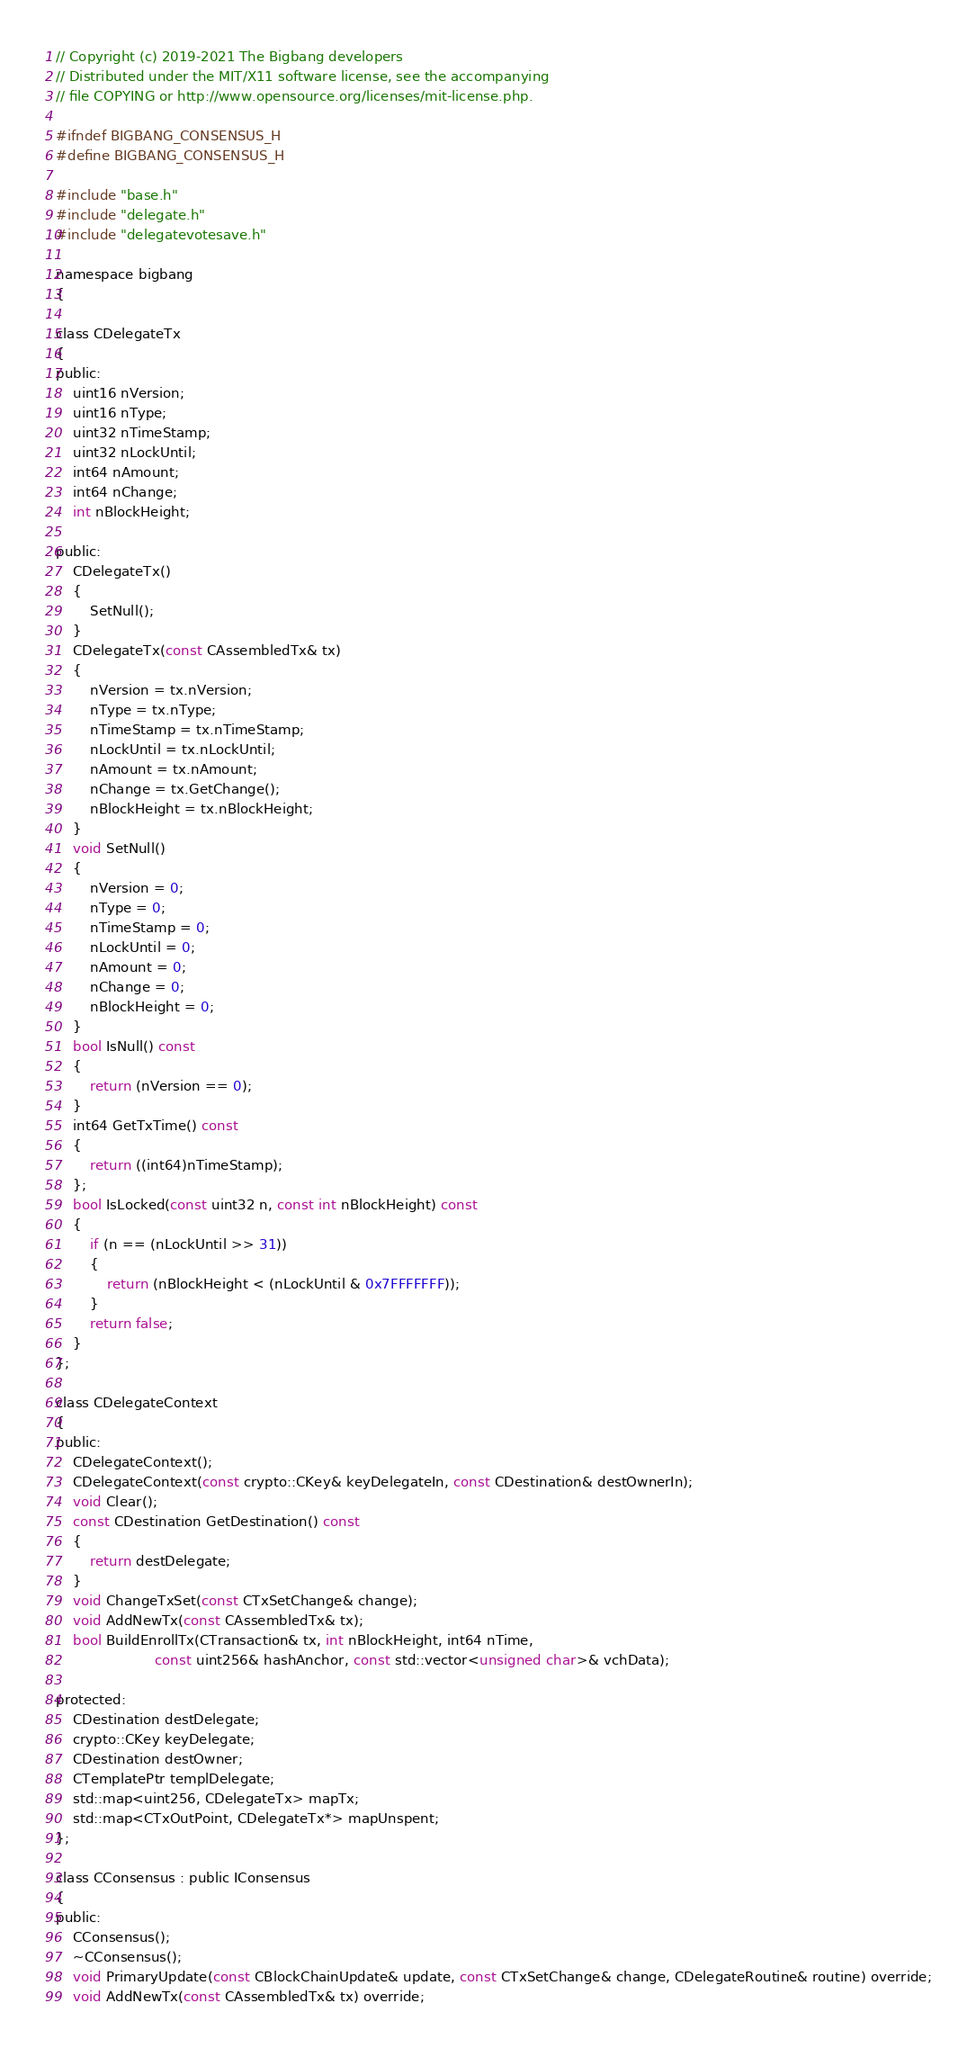Convert code to text. <code><loc_0><loc_0><loc_500><loc_500><_C_>// Copyright (c) 2019-2021 The Bigbang developers
// Distributed under the MIT/X11 software license, see the accompanying
// file COPYING or http://www.opensource.org/licenses/mit-license.php.

#ifndef BIGBANG_CONSENSUS_H
#define BIGBANG_CONSENSUS_H

#include "base.h"
#include "delegate.h"
#include "delegatevotesave.h"

namespace bigbang
{

class CDelegateTx
{
public:
    uint16 nVersion;
    uint16 nType;
    uint32 nTimeStamp;
    uint32 nLockUntil;
    int64 nAmount;
    int64 nChange;
    int nBlockHeight;

public:
    CDelegateTx()
    {
        SetNull();
    }
    CDelegateTx(const CAssembledTx& tx)
    {
        nVersion = tx.nVersion;
        nType = tx.nType;
        nTimeStamp = tx.nTimeStamp;
        nLockUntil = tx.nLockUntil;
        nAmount = tx.nAmount;
        nChange = tx.GetChange();
        nBlockHeight = tx.nBlockHeight;
    }
    void SetNull()
    {
        nVersion = 0;
        nType = 0;
        nTimeStamp = 0;
        nLockUntil = 0;
        nAmount = 0;
        nChange = 0;
        nBlockHeight = 0;
    }
    bool IsNull() const
    {
        return (nVersion == 0);
    }
    int64 GetTxTime() const
    {
        return ((int64)nTimeStamp);
    };
    bool IsLocked(const uint32 n, const int nBlockHeight) const
    {
        if (n == (nLockUntil >> 31))
        {
            return (nBlockHeight < (nLockUntil & 0x7FFFFFFF));
        }
        return false;
    }
};

class CDelegateContext
{
public:
    CDelegateContext();
    CDelegateContext(const crypto::CKey& keyDelegateIn, const CDestination& destOwnerIn);
    void Clear();
    const CDestination GetDestination() const
    {
        return destDelegate;
    }
    void ChangeTxSet(const CTxSetChange& change);
    void AddNewTx(const CAssembledTx& tx);
    bool BuildEnrollTx(CTransaction& tx, int nBlockHeight, int64 nTime,
                       const uint256& hashAnchor, const std::vector<unsigned char>& vchData);

protected:
    CDestination destDelegate;
    crypto::CKey keyDelegate;
    CDestination destOwner;
    CTemplatePtr templDelegate;
    std::map<uint256, CDelegateTx> mapTx;
    std::map<CTxOutPoint, CDelegateTx*> mapUnspent;
};

class CConsensus : public IConsensus
{
public:
    CConsensus();
    ~CConsensus();
    void PrimaryUpdate(const CBlockChainUpdate& update, const CTxSetChange& change, CDelegateRoutine& routine) override;
    void AddNewTx(const CAssembledTx& tx) override;</code> 